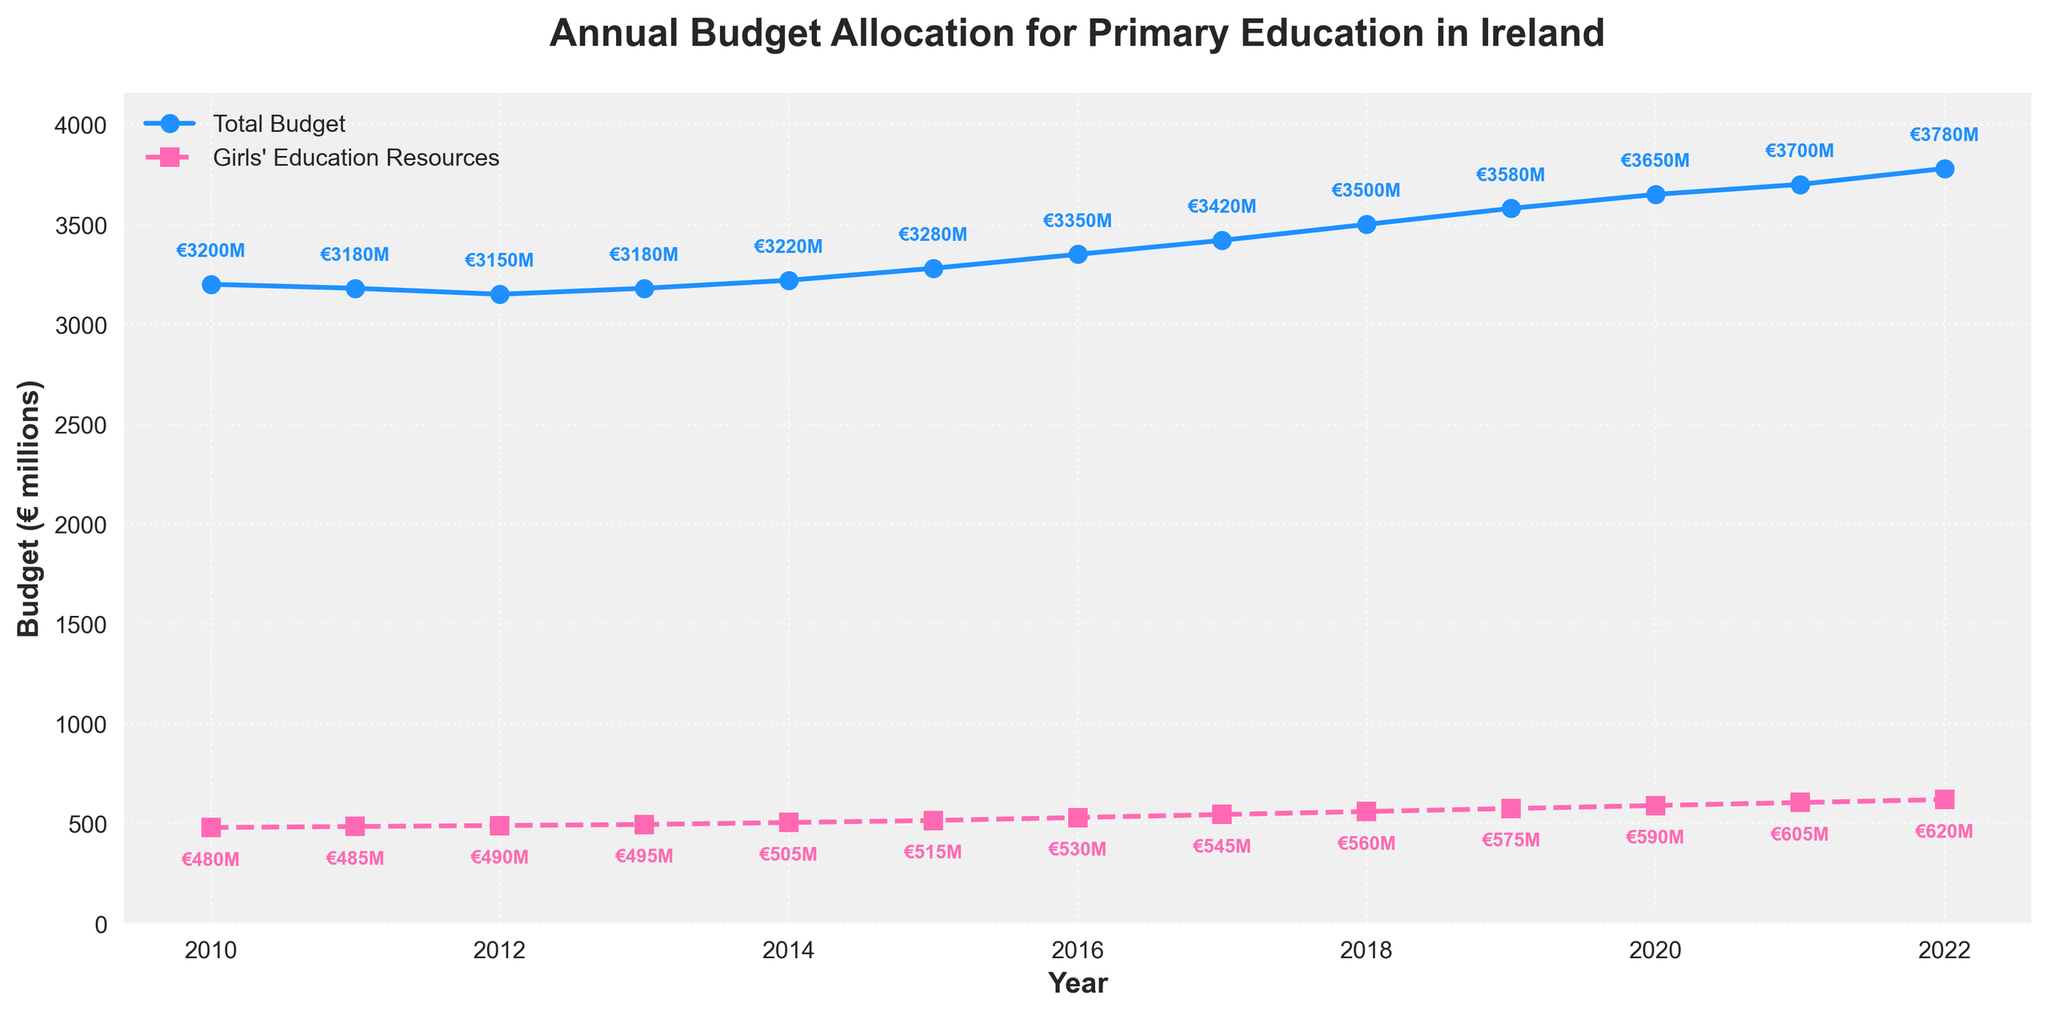What's the total annual budget for primary education in Ireland in 2012? Look for the year 2012 on the x-axis and find the corresponding y-axis value for the "Total Budget" line (marked with circles). The y-value is 3150 million euros.
Answer: 3150 million euros How much did the budget for girls' education resources increase from 2016 to 2019? Identify the y-values of the "Girls' Education Resources" line (marked with squares) for the years 2016 (530 million euros) and 2019 (575 million euros). The increase is 575 - 530 = 45 million euros.
Answer: 45 million euros Is there any year where the budget for girls' education resources remained the same as the previous year? Examine the "Girls' Education Resources" line to see if any two consecutive points are at the same y-value. No two consecutive points share the same value. Therefore, the budget changes every year.
Answer: No During which year did the total budget cross the 3400 million euros mark for the first time? Observe the "Total Budget" line to find the first occurrence where the value exceeds 3400 million euros. It first crosses this threshold in 2017.
Answer: 2017 What's the approximate ratio of total budget to girls' education resources in 2021? For 2021, the total budget is 3700 million euros, and the girls' education resources are 605 million euros. The ratio is approximately 3700 / 605 ≈ 6.11.
Answer: 6.11 By how much did the total budget change from 2010 to 2013? The total budget for 2010 is 3200 million euros, and for 2013 it is 3180 million euros. The change is 3180 - 3200 = -20 million euros.
Answer: -20 million euros Which year saw the highest allocation to girls' education resources? Look at the highest point on the "Girls' Education Resources" line. It occurs in 2022 with 620 million euros.
Answer: 2022 Was the budget for girls' education resources consistently increasing or did it have any dips? The "Girls' Education Resources" line shows a steady year-over-year increase without any drops.
Answer: Consistently increasing 